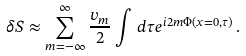<formula> <loc_0><loc_0><loc_500><loc_500>\delta S \approx \sum _ { m = - \infty } ^ { \infty } \frac { v _ { m } } { 2 } \int \, d \tau e ^ { i 2 m \Phi ( x = 0 , \tau ) } \, .</formula> 